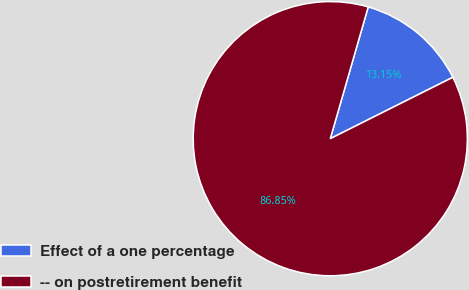Convert chart. <chart><loc_0><loc_0><loc_500><loc_500><pie_chart><fcel>Effect of a one percentage<fcel>-- on postretirement benefit<nl><fcel>13.15%<fcel>86.85%<nl></chart> 